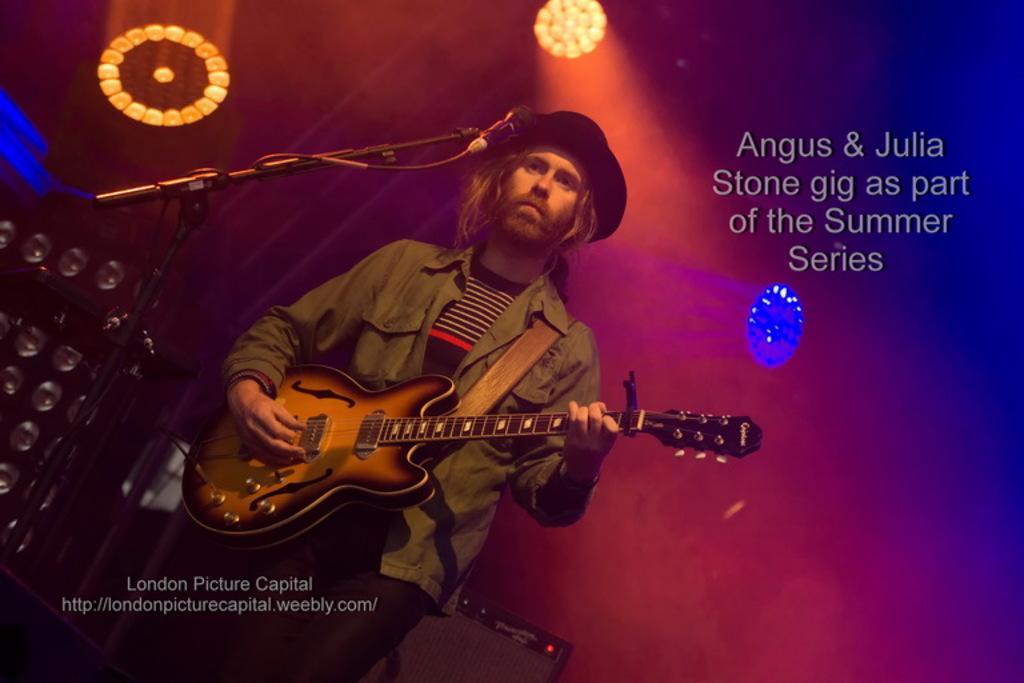Please provide a concise description of this image. Here we can see a man playing a guitar with a microphone in front of him, he is wearing a hat, behind him we can see colorful lights present here and there 